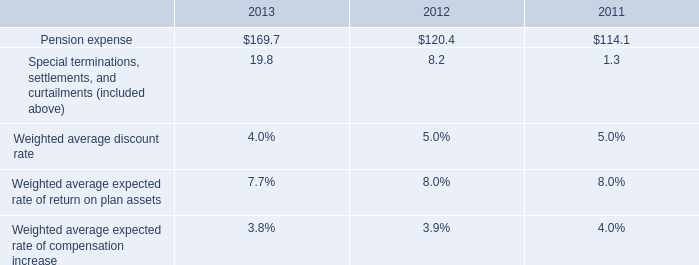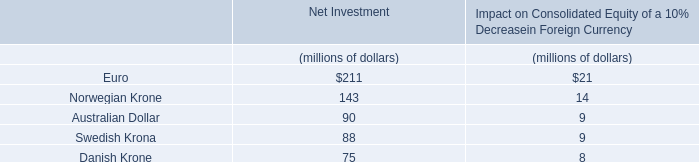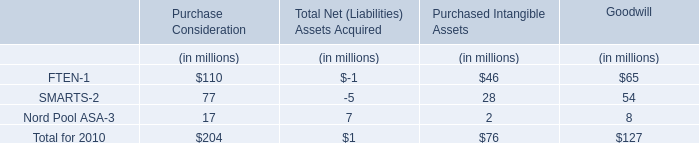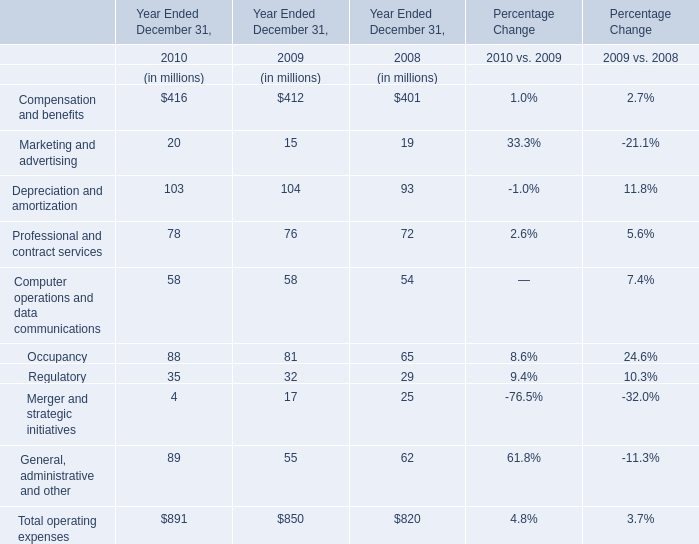considering the years 2012-2013 , what is the increase observed in the cash contributions to funded plans and benefit payments for unfunded plans? 
Computations: (((300.8 / 76.4) * 100) - 100)
Answer: 293.71728. 